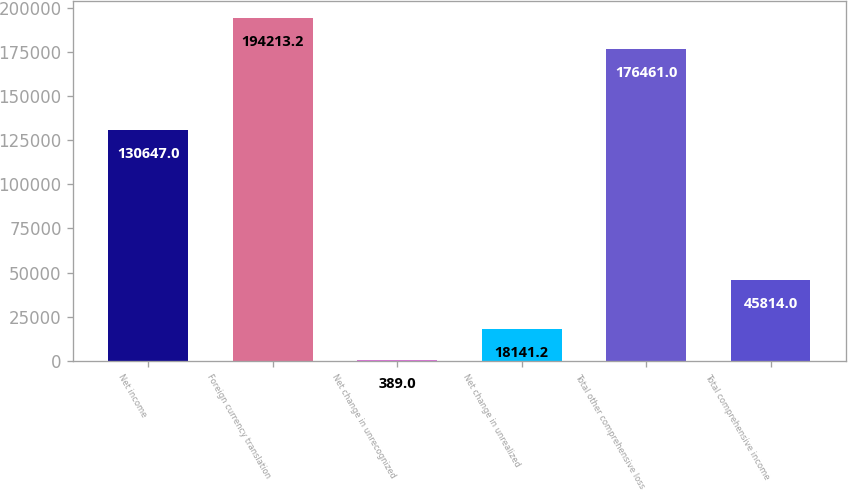<chart> <loc_0><loc_0><loc_500><loc_500><bar_chart><fcel>Net income<fcel>Foreign currency translation<fcel>Net change in unrecognized<fcel>Net change in unrealized<fcel>Total other comprehensive loss<fcel>Total comprehensive income<nl><fcel>130647<fcel>194213<fcel>389<fcel>18141.2<fcel>176461<fcel>45814<nl></chart> 